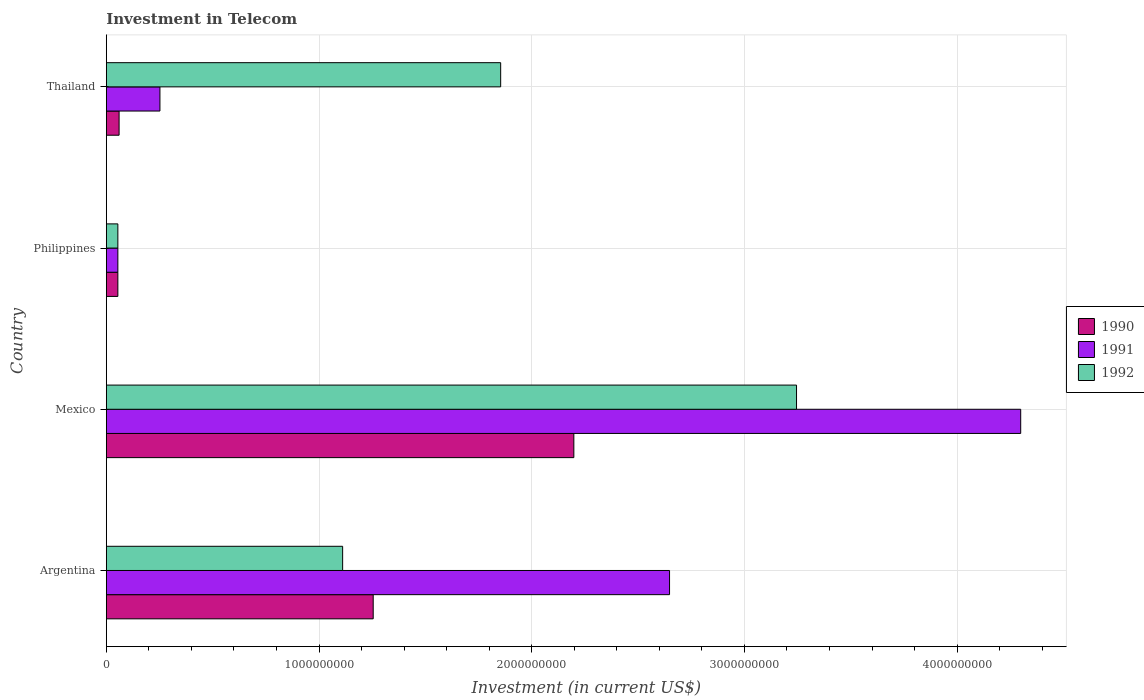How many groups of bars are there?
Provide a short and direct response. 4. Are the number of bars on each tick of the Y-axis equal?
Offer a very short reply. Yes. What is the label of the 1st group of bars from the top?
Your answer should be very brief. Thailand. In how many cases, is the number of bars for a given country not equal to the number of legend labels?
Your answer should be very brief. 0. What is the amount invested in telecom in 1991 in Thailand?
Ensure brevity in your answer.  2.52e+08. Across all countries, what is the maximum amount invested in telecom in 1991?
Your answer should be compact. 4.30e+09. Across all countries, what is the minimum amount invested in telecom in 1990?
Provide a short and direct response. 5.42e+07. In which country was the amount invested in telecom in 1992 minimum?
Make the answer very short. Philippines. What is the total amount invested in telecom in 1992 in the graph?
Offer a very short reply. 6.26e+09. What is the difference between the amount invested in telecom in 1992 in Philippines and that in Thailand?
Your answer should be compact. -1.80e+09. What is the difference between the amount invested in telecom in 1991 in Argentina and the amount invested in telecom in 1990 in Philippines?
Your answer should be compact. 2.59e+09. What is the average amount invested in telecom in 1991 per country?
Ensure brevity in your answer.  1.81e+09. What is the difference between the amount invested in telecom in 1990 and amount invested in telecom in 1991 in Thailand?
Provide a short and direct response. -1.92e+08. What is the ratio of the amount invested in telecom in 1991 in Philippines to that in Thailand?
Give a very brief answer. 0.22. Is the difference between the amount invested in telecom in 1990 in Philippines and Thailand greater than the difference between the amount invested in telecom in 1991 in Philippines and Thailand?
Ensure brevity in your answer.  Yes. What is the difference between the highest and the second highest amount invested in telecom in 1990?
Offer a very short reply. 9.43e+08. What is the difference between the highest and the lowest amount invested in telecom in 1992?
Keep it short and to the point. 3.19e+09. In how many countries, is the amount invested in telecom in 1990 greater than the average amount invested in telecom in 1990 taken over all countries?
Provide a succinct answer. 2. What does the 2nd bar from the bottom in Argentina represents?
Provide a short and direct response. 1991. Is it the case that in every country, the sum of the amount invested in telecom in 1990 and amount invested in telecom in 1991 is greater than the amount invested in telecom in 1992?
Keep it short and to the point. No. Are all the bars in the graph horizontal?
Offer a terse response. Yes. How many countries are there in the graph?
Your answer should be compact. 4. Are the values on the major ticks of X-axis written in scientific E-notation?
Offer a very short reply. No. Does the graph contain grids?
Provide a succinct answer. Yes. What is the title of the graph?
Offer a terse response. Investment in Telecom. What is the label or title of the X-axis?
Your response must be concise. Investment (in current US$). What is the label or title of the Y-axis?
Keep it short and to the point. Country. What is the Investment (in current US$) in 1990 in Argentina?
Give a very brief answer. 1.25e+09. What is the Investment (in current US$) in 1991 in Argentina?
Your response must be concise. 2.65e+09. What is the Investment (in current US$) of 1992 in Argentina?
Your answer should be very brief. 1.11e+09. What is the Investment (in current US$) of 1990 in Mexico?
Offer a terse response. 2.20e+09. What is the Investment (in current US$) of 1991 in Mexico?
Make the answer very short. 4.30e+09. What is the Investment (in current US$) of 1992 in Mexico?
Your answer should be compact. 3.24e+09. What is the Investment (in current US$) in 1990 in Philippines?
Offer a very short reply. 5.42e+07. What is the Investment (in current US$) of 1991 in Philippines?
Provide a succinct answer. 5.42e+07. What is the Investment (in current US$) in 1992 in Philippines?
Offer a terse response. 5.42e+07. What is the Investment (in current US$) in 1990 in Thailand?
Offer a terse response. 6.00e+07. What is the Investment (in current US$) in 1991 in Thailand?
Provide a succinct answer. 2.52e+08. What is the Investment (in current US$) in 1992 in Thailand?
Your response must be concise. 1.85e+09. Across all countries, what is the maximum Investment (in current US$) of 1990?
Offer a very short reply. 2.20e+09. Across all countries, what is the maximum Investment (in current US$) in 1991?
Give a very brief answer. 4.30e+09. Across all countries, what is the maximum Investment (in current US$) of 1992?
Your response must be concise. 3.24e+09. Across all countries, what is the minimum Investment (in current US$) of 1990?
Keep it short and to the point. 5.42e+07. Across all countries, what is the minimum Investment (in current US$) of 1991?
Offer a very short reply. 5.42e+07. Across all countries, what is the minimum Investment (in current US$) of 1992?
Make the answer very short. 5.42e+07. What is the total Investment (in current US$) of 1990 in the graph?
Provide a succinct answer. 3.57e+09. What is the total Investment (in current US$) of 1991 in the graph?
Give a very brief answer. 7.25e+09. What is the total Investment (in current US$) in 1992 in the graph?
Your response must be concise. 6.26e+09. What is the difference between the Investment (in current US$) of 1990 in Argentina and that in Mexico?
Offer a terse response. -9.43e+08. What is the difference between the Investment (in current US$) of 1991 in Argentina and that in Mexico?
Your answer should be compact. -1.65e+09. What is the difference between the Investment (in current US$) of 1992 in Argentina and that in Mexico?
Make the answer very short. -2.13e+09. What is the difference between the Investment (in current US$) of 1990 in Argentina and that in Philippines?
Ensure brevity in your answer.  1.20e+09. What is the difference between the Investment (in current US$) in 1991 in Argentina and that in Philippines?
Provide a short and direct response. 2.59e+09. What is the difference between the Investment (in current US$) in 1992 in Argentina and that in Philippines?
Ensure brevity in your answer.  1.06e+09. What is the difference between the Investment (in current US$) of 1990 in Argentina and that in Thailand?
Provide a succinct answer. 1.19e+09. What is the difference between the Investment (in current US$) of 1991 in Argentina and that in Thailand?
Your answer should be very brief. 2.40e+09. What is the difference between the Investment (in current US$) of 1992 in Argentina and that in Thailand?
Make the answer very short. -7.43e+08. What is the difference between the Investment (in current US$) in 1990 in Mexico and that in Philippines?
Ensure brevity in your answer.  2.14e+09. What is the difference between the Investment (in current US$) of 1991 in Mexico and that in Philippines?
Provide a succinct answer. 4.24e+09. What is the difference between the Investment (in current US$) of 1992 in Mexico and that in Philippines?
Keep it short and to the point. 3.19e+09. What is the difference between the Investment (in current US$) of 1990 in Mexico and that in Thailand?
Give a very brief answer. 2.14e+09. What is the difference between the Investment (in current US$) of 1991 in Mexico and that in Thailand?
Keep it short and to the point. 4.05e+09. What is the difference between the Investment (in current US$) in 1992 in Mexico and that in Thailand?
Your answer should be compact. 1.39e+09. What is the difference between the Investment (in current US$) in 1990 in Philippines and that in Thailand?
Your response must be concise. -5.80e+06. What is the difference between the Investment (in current US$) in 1991 in Philippines and that in Thailand?
Offer a very short reply. -1.98e+08. What is the difference between the Investment (in current US$) in 1992 in Philippines and that in Thailand?
Offer a terse response. -1.80e+09. What is the difference between the Investment (in current US$) of 1990 in Argentina and the Investment (in current US$) of 1991 in Mexico?
Offer a very short reply. -3.04e+09. What is the difference between the Investment (in current US$) in 1990 in Argentina and the Investment (in current US$) in 1992 in Mexico?
Offer a terse response. -1.99e+09. What is the difference between the Investment (in current US$) of 1991 in Argentina and the Investment (in current US$) of 1992 in Mexico?
Make the answer very short. -5.97e+08. What is the difference between the Investment (in current US$) of 1990 in Argentina and the Investment (in current US$) of 1991 in Philippines?
Give a very brief answer. 1.20e+09. What is the difference between the Investment (in current US$) of 1990 in Argentina and the Investment (in current US$) of 1992 in Philippines?
Your response must be concise. 1.20e+09. What is the difference between the Investment (in current US$) of 1991 in Argentina and the Investment (in current US$) of 1992 in Philippines?
Your answer should be compact. 2.59e+09. What is the difference between the Investment (in current US$) in 1990 in Argentina and the Investment (in current US$) in 1991 in Thailand?
Your answer should be compact. 1.00e+09. What is the difference between the Investment (in current US$) in 1990 in Argentina and the Investment (in current US$) in 1992 in Thailand?
Give a very brief answer. -5.99e+08. What is the difference between the Investment (in current US$) in 1991 in Argentina and the Investment (in current US$) in 1992 in Thailand?
Provide a short and direct response. 7.94e+08. What is the difference between the Investment (in current US$) in 1990 in Mexico and the Investment (in current US$) in 1991 in Philippines?
Provide a succinct answer. 2.14e+09. What is the difference between the Investment (in current US$) in 1990 in Mexico and the Investment (in current US$) in 1992 in Philippines?
Offer a terse response. 2.14e+09. What is the difference between the Investment (in current US$) of 1991 in Mexico and the Investment (in current US$) of 1992 in Philippines?
Ensure brevity in your answer.  4.24e+09. What is the difference between the Investment (in current US$) in 1990 in Mexico and the Investment (in current US$) in 1991 in Thailand?
Your answer should be very brief. 1.95e+09. What is the difference between the Investment (in current US$) in 1990 in Mexico and the Investment (in current US$) in 1992 in Thailand?
Offer a terse response. 3.44e+08. What is the difference between the Investment (in current US$) of 1991 in Mexico and the Investment (in current US$) of 1992 in Thailand?
Your answer should be compact. 2.44e+09. What is the difference between the Investment (in current US$) of 1990 in Philippines and the Investment (in current US$) of 1991 in Thailand?
Provide a short and direct response. -1.98e+08. What is the difference between the Investment (in current US$) of 1990 in Philippines and the Investment (in current US$) of 1992 in Thailand?
Your response must be concise. -1.80e+09. What is the difference between the Investment (in current US$) of 1991 in Philippines and the Investment (in current US$) of 1992 in Thailand?
Ensure brevity in your answer.  -1.80e+09. What is the average Investment (in current US$) of 1990 per country?
Your answer should be very brief. 8.92e+08. What is the average Investment (in current US$) of 1991 per country?
Offer a very short reply. 1.81e+09. What is the average Investment (in current US$) in 1992 per country?
Your answer should be compact. 1.57e+09. What is the difference between the Investment (in current US$) in 1990 and Investment (in current US$) in 1991 in Argentina?
Ensure brevity in your answer.  -1.39e+09. What is the difference between the Investment (in current US$) of 1990 and Investment (in current US$) of 1992 in Argentina?
Your answer should be very brief. 1.44e+08. What is the difference between the Investment (in current US$) in 1991 and Investment (in current US$) in 1992 in Argentina?
Give a very brief answer. 1.54e+09. What is the difference between the Investment (in current US$) in 1990 and Investment (in current US$) in 1991 in Mexico?
Provide a short and direct response. -2.10e+09. What is the difference between the Investment (in current US$) in 1990 and Investment (in current US$) in 1992 in Mexico?
Your answer should be very brief. -1.05e+09. What is the difference between the Investment (in current US$) in 1991 and Investment (in current US$) in 1992 in Mexico?
Ensure brevity in your answer.  1.05e+09. What is the difference between the Investment (in current US$) of 1990 and Investment (in current US$) of 1991 in Philippines?
Provide a succinct answer. 0. What is the difference between the Investment (in current US$) of 1991 and Investment (in current US$) of 1992 in Philippines?
Your response must be concise. 0. What is the difference between the Investment (in current US$) of 1990 and Investment (in current US$) of 1991 in Thailand?
Provide a succinct answer. -1.92e+08. What is the difference between the Investment (in current US$) in 1990 and Investment (in current US$) in 1992 in Thailand?
Ensure brevity in your answer.  -1.79e+09. What is the difference between the Investment (in current US$) in 1991 and Investment (in current US$) in 1992 in Thailand?
Offer a terse response. -1.60e+09. What is the ratio of the Investment (in current US$) in 1990 in Argentina to that in Mexico?
Provide a succinct answer. 0.57. What is the ratio of the Investment (in current US$) in 1991 in Argentina to that in Mexico?
Provide a succinct answer. 0.62. What is the ratio of the Investment (in current US$) in 1992 in Argentina to that in Mexico?
Offer a terse response. 0.34. What is the ratio of the Investment (in current US$) of 1990 in Argentina to that in Philippines?
Keep it short and to the point. 23.15. What is the ratio of the Investment (in current US$) in 1991 in Argentina to that in Philippines?
Give a very brief answer. 48.86. What is the ratio of the Investment (in current US$) of 1992 in Argentina to that in Philippines?
Provide a succinct answer. 20.5. What is the ratio of the Investment (in current US$) in 1990 in Argentina to that in Thailand?
Your answer should be very brief. 20.91. What is the ratio of the Investment (in current US$) in 1991 in Argentina to that in Thailand?
Provide a succinct answer. 10.51. What is the ratio of the Investment (in current US$) of 1992 in Argentina to that in Thailand?
Keep it short and to the point. 0.6. What is the ratio of the Investment (in current US$) in 1990 in Mexico to that in Philippines?
Provide a succinct answer. 40.55. What is the ratio of the Investment (in current US$) in 1991 in Mexico to that in Philippines?
Provide a short and direct response. 79.32. What is the ratio of the Investment (in current US$) in 1992 in Mexico to that in Philippines?
Keep it short and to the point. 59.87. What is the ratio of the Investment (in current US$) of 1990 in Mexico to that in Thailand?
Your response must be concise. 36.63. What is the ratio of the Investment (in current US$) of 1991 in Mexico to that in Thailand?
Provide a succinct answer. 17.06. What is the ratio of the Investment (in current US$) in 1992 in Mexico to that in Thailand?
Ensure brevity in your answer.  1.75. What is the ratio of the Investment (in current US$) in 1990 in Philippines to that in Thailand?
Ensure brevity in your answer.  0.9. What is the ratio of the Investment (in current US$) of 1991 in Philippines to that in Thailand?
Give a very brief answer. 0.22. What is the ratio of the Investment (in current US$) in 1992 in Philippines to that in Thailand?
Offer a very short reply. 0.03. What is the difference between the highest and the second highest Investment (in current US$) in 1990?
Offer a terse response. 9.43e+08. What is the difference between the highest and the second highest Investment (in current US$) in 1991?
Your answer should be compact. 1.65e+09. What is the difference between the highest and the second highest Investment (in current US$) of 1992?
Give a very brief answer. 1.39e+09. What is the difference between the highest and the lowest Investment (in current US$) of 1990?
Provide a succinct answer. 2.14e+09. What is the difference between the highest and the lowest Investment (in current US$) of 1991?
Your answer should be very brief. 4.24e+09. What is the difference between the highest and the lowest Investment (in current US$) of 1992?
Keep it short and to the point. 3.19e+09. 